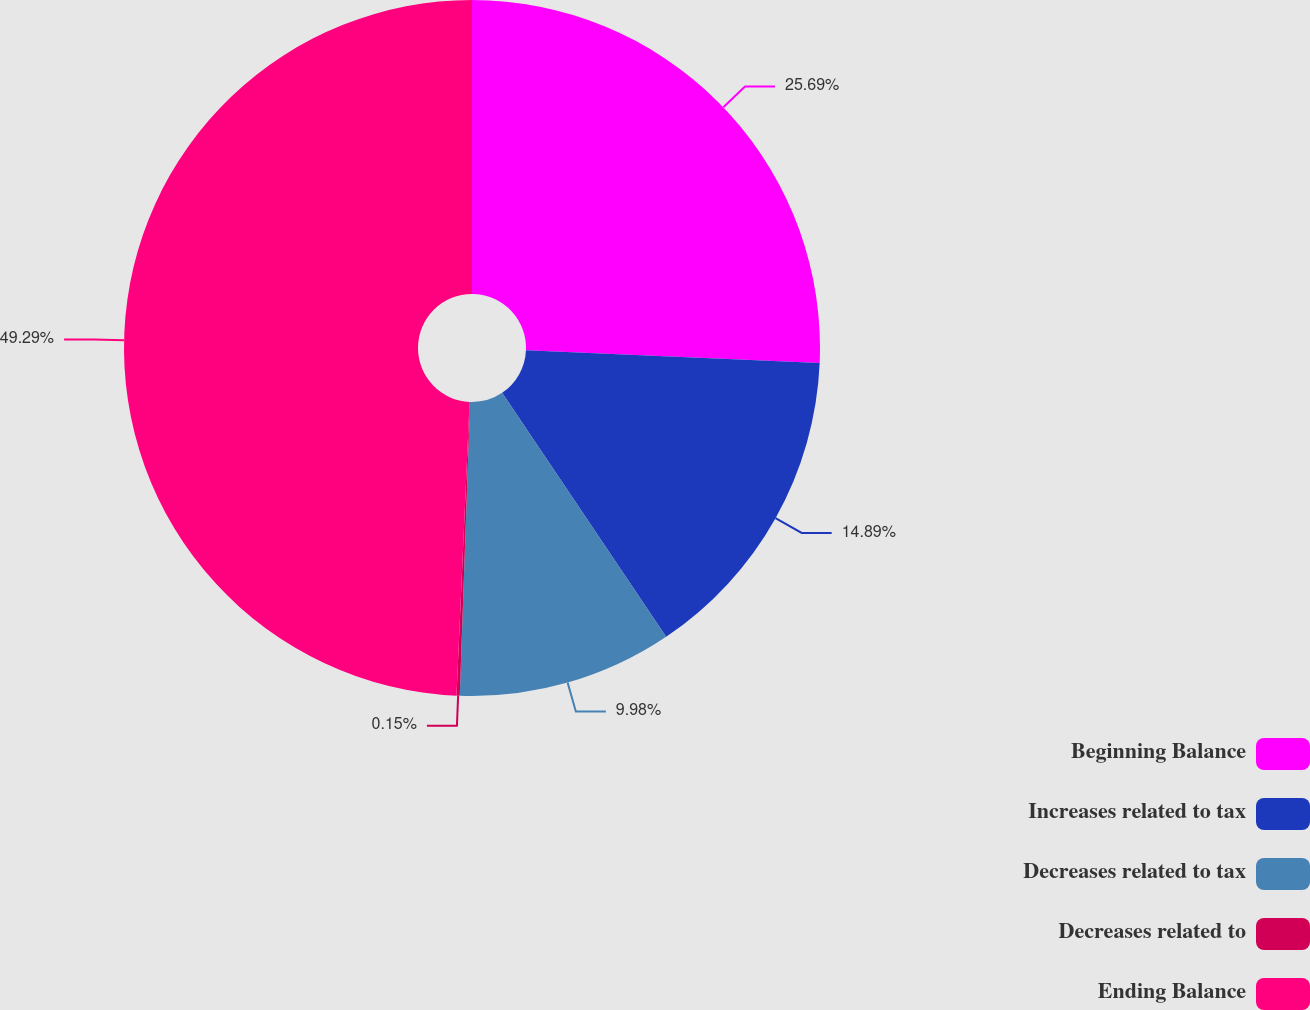Convert chart. <chart><loc_0><loc_0><loc_500><loc_500><pie_chart><fcel>Beginning Balance<fcel>Increases related to tax<fcel>Decreases related to tax<fcel>Decreases related to<fcel>Ending Balance<nl><fcel>25.69%<fcel>14.89%<fcel>9.98%<fcel>0.15%<fcel>49.29%<nl></chart> 